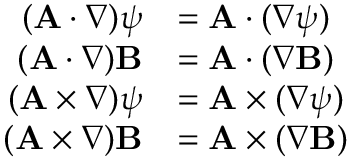<formula> <loc_0><loc_0><loc_500><loc_500>{ \begin{array} { r l } { ( A \cdot \nabla ) \psi } & { = A \cdot ( \nabla \psi ) } \\ { ( A \cdot \nabla ) B } & { = A \cdot ( \nabla B ) } \\ { ( A \times \nabla ) \psi } & { = A \times ( \nabla \psi ) } \\ { ( A \times \nabla ) B } & { = A \times ( \nabla B ) } \end{array} }</formula> 